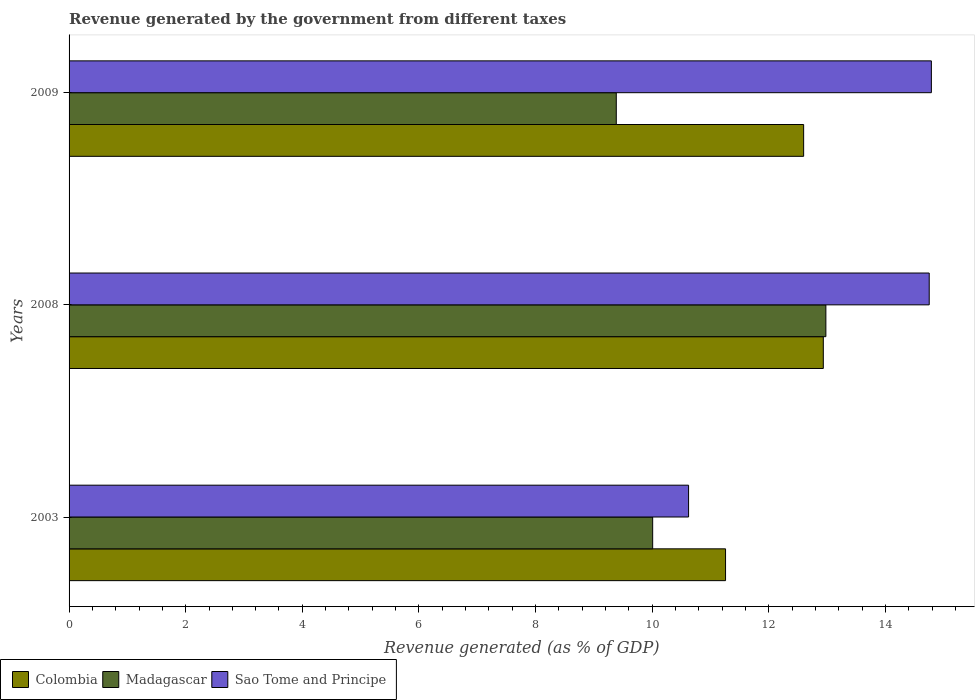How many bars are there on the 2nd tick from the top?
Give a very brief answer. 3. How many bars are there on the 1st tick from the bottom?
Keep it short and to the point. 3. What is the revenue generated by the government in Colombia in 2008?
Make the answer very short. 12.94. Across all years, what is the maximum revenue generated by the government in Sao Tome and Principe?
Ensure brevity in your answer.  14.79. Across all years, what is the minimum revenue generated by the government in Madagascar?
Your answer should be compact. 9.38. In which year was the revenue generated by the government in Madagascar maximum?
Provide a short and direct response. 2008. What is the total revenue generated by the government in Madagascar in the graph?
Provide a short and direct response. 32.37. What is the difference between the revenue generated by the government in Colombia in 2008 and that in 2009?
Provide a succinct answer. 0.34. What is the difference between the revenue generated by the government in Colombia in 2008 and the revenue generated by the government in Madagascar in 2003?
Ensure brevity in your answer.  2.93. What is the average revenue generated by the government in Colombia per year?
Your response must be concise. 12.26. In the year 2009, what is the difference between the revenue generated by the government in Sao Tome and Principe and revenue generated by the government in Madagascar?
Ensure brevity in your answer.  5.4. What is the ratio of the revenue generated by the government in Sao Tome and Principe in 2008 to that in 2009?
Offer a very short reply. 1. What is the difference between the highest and the second highest revenue generated by the government in Madagascar?
Provide a short and direct response. 2.97. What is the difference between the highest and the lowest revenue generated by the government in Colombia?
Your response must be concise. 1.68. Is the sum of the revenue generated by the government in Sao Tome and Principe in 2003 and 2009 greater than the maximum revenue generated by the government in Colombia across all years?
Provide a short and direct response. Yes. What does the 3rd bar from the top in 2008 represents?
Provide a succinct answer. Colombia. What does the 3rd bar from the bottom in 2008 represents?
Your answer should be compact. Sao Tome and Principe. Are all the bars in the graph horizontal?
Offer a terse response. Yes. How many years are there in the graph?
Offer a terse response. 3. Does the graph contain grids?
Your answer should be very brief. No. How are the legend labels stacked?
Your response must be concise. Horizontal. What is the title of the graph?
Your response must be concise. Revenue generated by the government from different taxes. What is the label or title of the X-axis?
Keep it short and to the point. Revenue generated (as % of GDP). What is the Revenue generated (as % of GDP) of Colombia in 2003?
Ensure brevity in your answer.  11.26. What is the Revenue generated (as % of GDP) in Madagascar in 2003?
Your response must be concise. 10.01. What is the Revenue generated (as % of GDP) in Sao Tome and Principe in 2003?
Provide a short and direct response. 10.62. What is the Revenue generated (as % of GDP) in Colombia in 2008?
Offer a terse response. 12.94. What is the Revenue generated (as % of GDP) of Madagascar in 2008?
Give a very brief answer. 12.98. What is the Revenue generated (as % of GDP) in Sao Tome and Principe in 2008?
Provide a short and direct response. 14.75. What is the Revenue generated (as % of GDP) of Colombia in 2009?
Offer a terse response. 12.6. What is the Revenue generated (as % of GDP) of Madagascar in 2009?
Give a very brief answer. 9.38. What is the Revenue generated (as % of GDP) in Sao Tome and Principe in 2009?
Make the answer very short. 14.79. Across all years, what is the maximum Revenue generated (as % of GDP) of Colombia?
Your answer should be compact. 12.94. Across all years, what is the maximum Revenue generated (as % of GDP) of Madagascar?
Your response must be concise. 12.98. Across all years, what is the maximum Revenue generated (as % of GDP) in Sao Tome and Principe?
Your answer should be very brief. 14.79. Across all years, what is the minimum Revenue generated (as % of GDP) in Colombia?
Make the answer very short. 11.26. Across all years, what is the minimum Revenue generated (as % of GDP) in Madagascar?
Provide a short and direct response. 9.38. Across all years, what is the minimum Revenue generated (as % of GDP) of Sao Tome and Principe?
Provide a short and direct response. 10.62. What is the total Revenue generated (as % of GDP) of Colombia in the graph?
Your answer should be very brief. 36.79. What is the total Revenue generated (as % of GDP) in Madagascar in the graph?
Your answer should be compact. 32.37. What is the total Revenue generated (as % of GDP) in Sao Tome and Principe in the graph?
Your answer should be compact. 40.17. What is the difference between the Revenue generated (as % of GDP) of Colombia in 2003 and that in 2008?
Your answer should be compact. -1.68. What is the difference between the Revenue generated (as % of GDP) in Madagascar in 2003 and that in 2008?
Keep it short and to the point. -2.97. What is the difference between the Revenue generated (as % of GDP) of Sao Tome and Principe in 2003 and that in 2008?
Your answer should be compact. -4.13. What is the difference between the Revenue generated (as % of GDP) in Colombia in 2003 and that in 2009?
Offer a terse response. -1.34. What is the difference between the Revenue generated (as % of GDP) in Madagascar in 2003 and that in 2009?
Offer a terse response. 0.62. What is the difference between the Revenue generated (as % of GDP) of Sao Tome and Principe in 2003 and that in 2009?
Make the answer very short. -4.16. What is the difference between the Revenue generated (as % of GDP) of Colombia in 2008 and that in 2009?
Make the answer very short. 0.34. What is the difference between the Revenue generated (as % of GDP) in Madagascar in 2008 and that in 2009?
Provide a short and direct response. 3.59. What is the difference between the Revenue generated (as % of GDP) in Sao Tome and Principe in 2008 and that in 2009?
Make the answer very short. -0.04. What is the difference between the Revenue generated (as % of GDP) of Colombia in 2003 and the Revenue generated (as % of GDP) of Madagascar in 2008?
Your answer should be compact. -1.72. What is the difference between the Revenue generated (as % of GDP) of Colombia in 2003 and the Revenue generated (as % of GDP) of Sao Tome and Principe in 2008?
Your answer should be very brief. -3.49. What is the difference between the Revenue generated (as % of GDP) in Madagascar in 2003 and the Revenue generated (as % of GDP) in Sao Tome and Principe in 2008?
Your answer should be very brief. -4.74. What is the difference between the Revenue generated (as % of GDP) of Colombia in 2003 and the Revenue generated (as % of GDP) of Madagascar in 2009?
Make the answer very short. 1.87. What is the difference between the Revenue generated (as % of GDP) in Colombia in 2003 and the Revenue generated (as % of GDP) in Sao Tome and Principe in 2009?
Offer a very short reply. -3.53. What is the difference between the Revenue generated (as % of GDP) of Madagascar in 2003 and the Revenue generated (as % of GDP) of Sao Tome and Principe in 2009?
Provide a short and direct response. -4.78. What is the difference between the Revenue generated (as % of GDP) of Colombia in 2008 and the Revenue generated (as % of GDP) of Madagascar in 2009?
Your response must be concise. 3.55. What is the difference between the Revenue generated (as % of GDP) in Colombia in 2008 and the Revenue generated (as % of GDP) in Sao Tome and Principe in 2009?
Offer a terse response. -1.85. What is the difference between the Revenue generated (as % of GDP) of Madagascar in 2008 and the Revenue generated (as % of GDP) of Sao Tome and Principe in 2009?
Keep it short and to the point. -1.81. What is the average Revenue generated (as % of GDP) in Colombia per year?
Offer a very short reply. 12.26. What is the average Revenue generated (as % of GDP) of Madagascar per year?
Your answer should be very brief. 10.79. What is the average Revenue generated (as % of GDP) in Sao Tome and Principe per year?
Ensure brevity in your answer.  13.39. In the year 2003, what is the difference between the Revenue generated (as % of GDP) of Colombia and Revenue generated (as % of GDP) of Madagascar?
Offer a terse response. 1.25. In the year 2003, what is the difference between the Revenue generated (as % of GDP) of Colombia and Revenue generated (as % of GDP) of Sao Tome and Principe?
Your answer should be compact. 0.63. In the year 2003, what is the difference between the Revenue generated (as % of GDP) in Madagascar and Revenue generated (as % of GDP) in Sao Tome and Principe?
Provide a succinct answer. -0.62. In the year 2008, what is the difference between the Revenue generated (as % of GDP) in Colombia and Revenue generated (as % of GDP) in Madagascar?
Your answer should be very brief. -0.04. In the year 2008, what is the difference between the Revenue generated (as % of GDP) in Colombia and Revenue generated (as % of GDP) in Sao Tome and Principe?
Provide a short and direct response. -1.82. In the year 2008, what is the difference between the Revenue generated (as % of GDP) in Madagascar and Revenue generated (as % of GDP) in Sao Tome and Principe?
Provide a short and direct response. -1.77. In the year 2009, what is the difference between the Revenue generated (as % of GDP) in Colombia and Revenue generated (as % of GDP) in Madagascar?
Your response must be concise. 3.21. In the year 2009, what is the difference between the Revenue generated (as % of GDP) in Colombia and Revenue generated (as % of GDP) in Sao Tome and Principe?
Ensure brevity in your answer.  -2.19. In the year 2009, what is the difference between the Revenue generated (as % of GDP) of Madagascar and Revenue generated (as % of GDP) of Sao Tome and Principe?
Keep it short and to the point. -5.4. What is the ratio of the Revenue generated (as % of GDP) in Colombia in 2003 to that in 2008?
Make the answer very short. 0.87. What is the ratio of the Revenue generated (as % of GDP) of Madagascar in 2003 to that in 2008?
Offer a terse response. 0.77. What is the ratio of the Revenue generated (as % of GDP) of Sao Tome and Principe in 2003 to that in 2008?
Offer a very short reply. 0.72. What is the ratio of the Revenue generated (as % of GDP) in Colombia in 2003 to that in 2009?
Provide a short and direct response. 0.89. What is the ratio of the Revenue generated (as % of GDP) in Madagascar in 2003 to that in 2009?
Ensure brevity in your answer.  1.07. What is the ratio of the Revenue generated (as % of GDP) of Sao Tome and Principe in 2003 to that in 2009?
Offer a terse response. 0.72. What is the ratio of the Revenue generated (as % of GDP) in Colombia in 2008 to that in 2009?
Provide a short and direct response. 1.03. What is the ratio of the Revenue generated (as % of GDP) of Madagascar in 2008 to that in 2009?
Provide a succinct answer. 1.38. What is the ratio of the Revenue generated (as % of GDP) in Sao Tome and Principe in 2008 to that in 2009?
Give a very brief answer. 1. What is the difference between the highest and the second highest Revenue generated (as % of GDP) in Colombia?
Keep it short and to the point. 0.34. What is the difference between the highest and the second highest Revenue generated (as % of GDP) of Madagascar?
Ensure brevity in your answer.  2.97. What is the difference between the highest and the second highest Revenue generated (as % of GDP) of Sao Tome and Principe?
Offer a terse response. 0.04. What is the difference between the highest and the lowest Revenue generated (as % of GDP) of Colombia?
Give a very brief answer. 1.68. What is the difference between the highest and the lowest Revenue generated (as % of GDP) in Madagascar?
Provide a succinct answer. 3.59. What is the difference between the highest and the lowest Revenue generated (as % of GDP) of Sao Tome and Principe?
Offer a terse response. 4.16. 